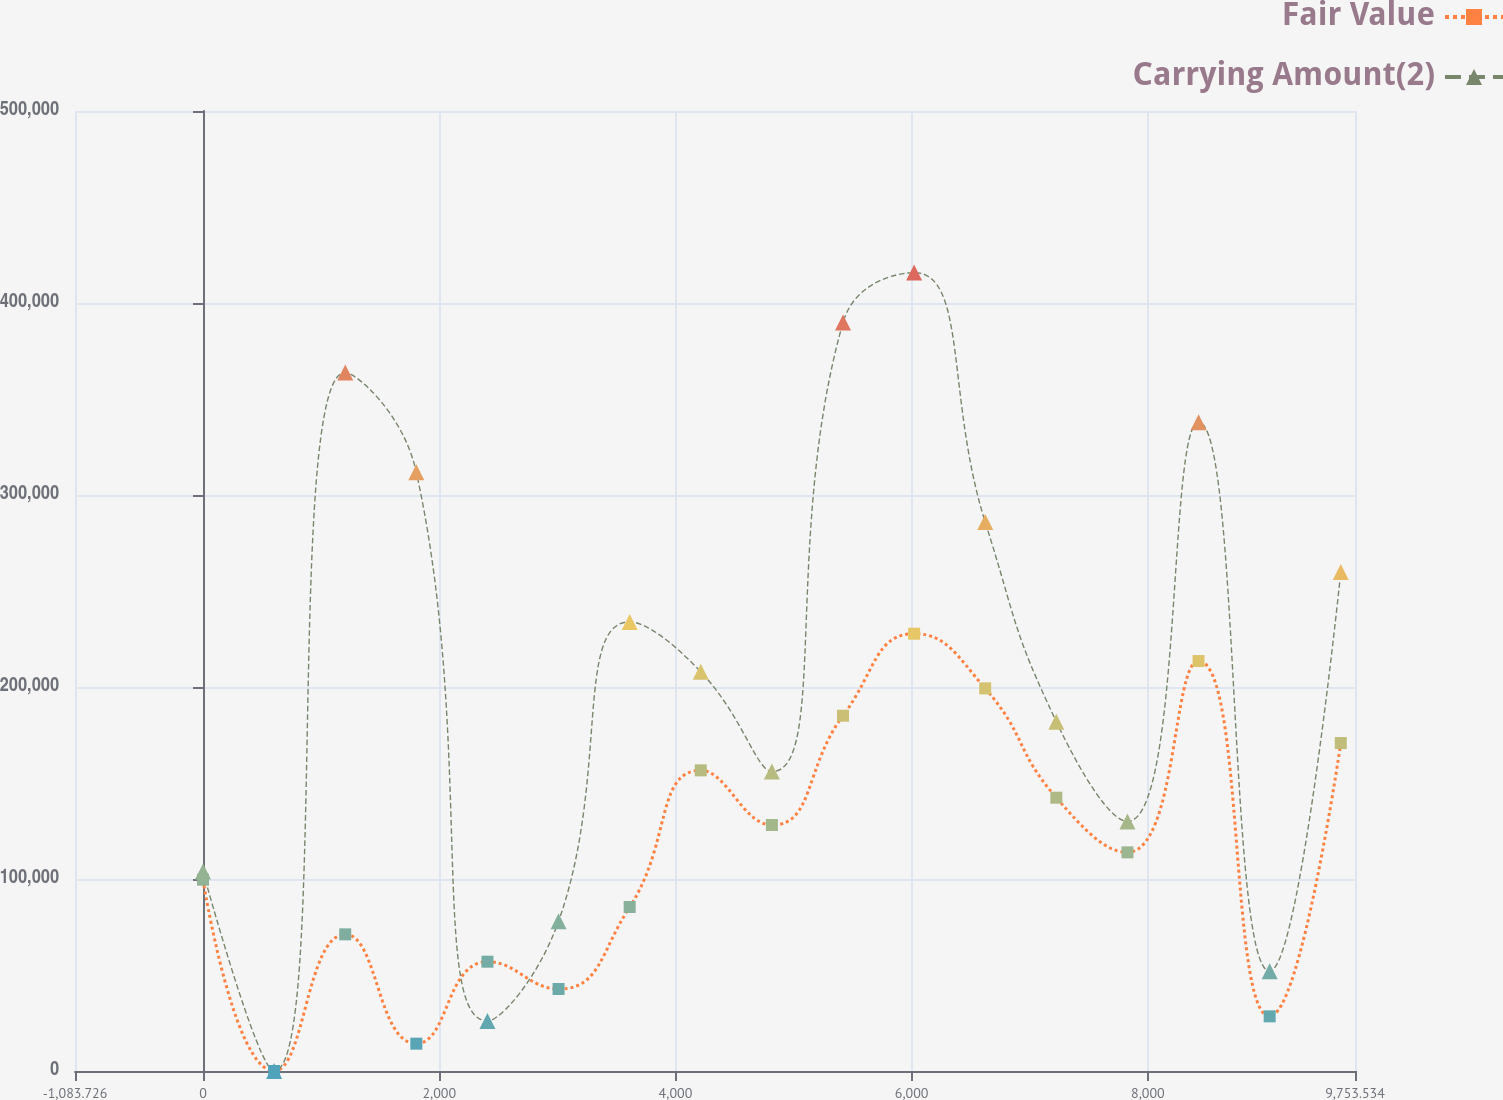Convert chart. <chart><loc_0><loc_0><loc_500><loc_500><line_chart><ecel><fcel>Fair Value<fcel>Carrying Amount(2)<nl><fcel>0<fcel>99641.1<fcel>103958<nl><fcel>602.07<fcel>0<fcel>0<nl><fcel>1204.14<fcel>71172.2<fcel>363853<nl><fcel>1806.21<fcel>14234.5<fcel>311874<nl><fcel>2408.28<fcel>56937.8<fcel>25989.5<nl><fcel>3010.35<fcel>42703.3<fcel>77968.6<nl><fcel>3612.42<fcel>85406.7<fcel>233906<nl><fcel>4214.49<fcel>156579<fcel>207916<nl><fcel>4816.56<fcel>128110<fcel>155937<nl><fcel>5418.63<fcel>185048<fcel>389843<nl><fcel>6020.7<fcel>227751<fcel>415832<nl><fcel>6622.77<fcel>199282<fcel>285885<nl><fcel>7224.84<fcel>142344<fcel>181927<nl><fcel>7826.91<fcel>113876<fcel>129948<nl><fcel>8428.98<fcel>213517<fcel>337864<nl><fcel>9031.05<fcel>28468.9<fcel>51979.1<nl><fcel>9633.12<fcel>170813<fcel>259895<nl><fcel>10235.2<fcel>241986<fcel>441822<nl><fcel>10837.3<fcel>256220<fcel>467812<nl></chart> 